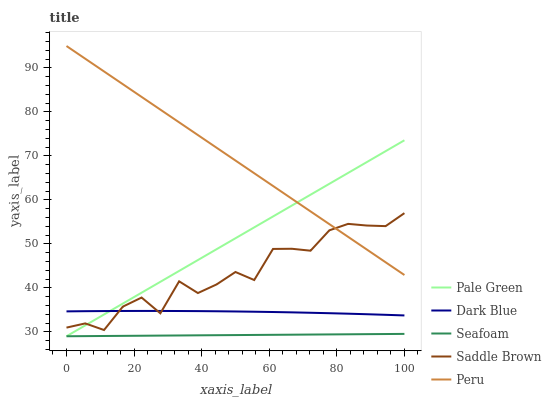Does Seafoam have the minimum area under the curve?
Answer yes or no. Yes. Does Peru have the maximum area under the curve?
Answer yes or no. Yes. Does Pale Green have the minimum area under the curve?
Answer yes or no. No. Does Pale Green have the maximum area under the curve?
Answer yes or no. No. Is Seafoam the smoothest?
Answer yes or no. Yes. Is Saddle Brown the roughest?
Answer yes or no. Yes. Is Pale Green the smoothest?
Answer yes or no. No. Is Pale Green the roughest?
Answer yes or no. No. Does Peru have the lowest value?
Answer yes or no. No. Does Peru have the highest value?
Answer yes or no. Yes. Does Pale Green have the highest value?
Answer yes or no. No. Is Seafoam less than Dark Blue?
Answer yes or no. Yes. Is Peru greater than Seafoam?
Answer yes or no. Yes. Does Pale Green intersect Peru?
Answer yes or no. Yes. Is Pale Green less than Peru?
Answer yes or no. No. Is Pale Green greater than Peru?
Answer yes or no. No. Does Seafoam intersect Dark Blue?
Answer yes or no. No. 